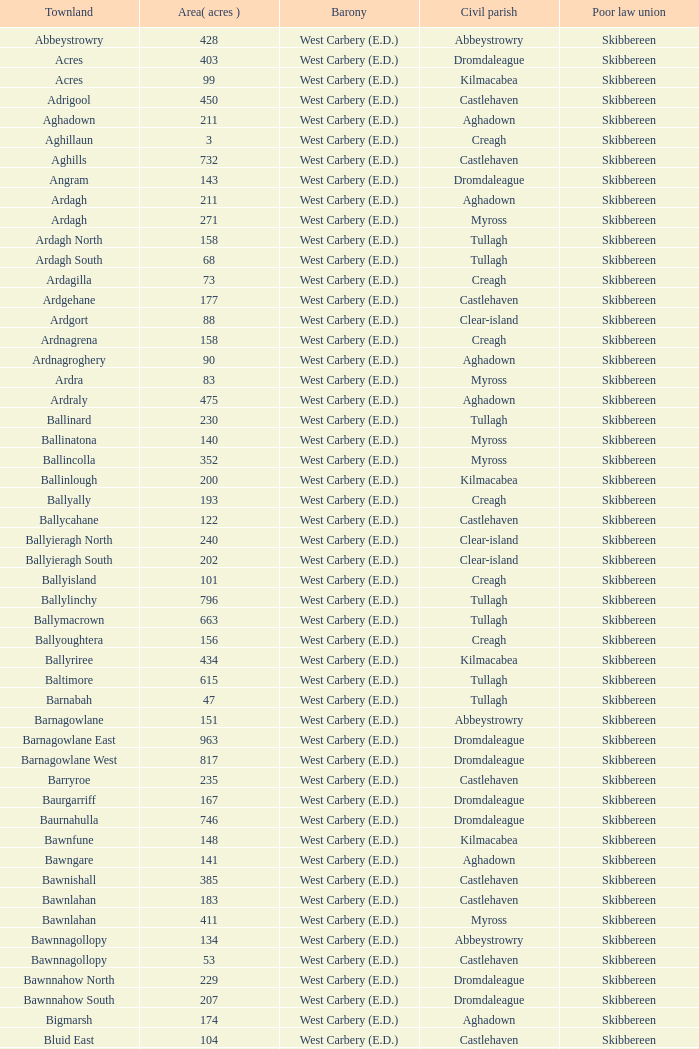When the land area is 276 acres, what are the baronies? West Carbery (E.D.). 